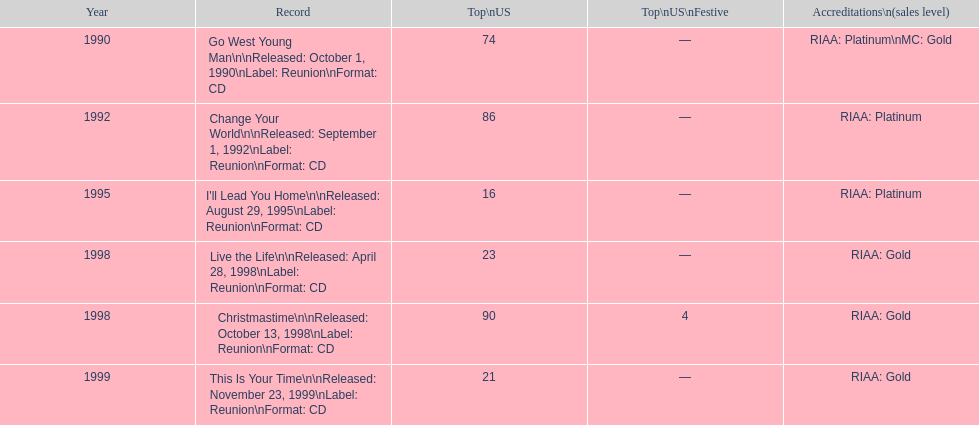Which michael w. smith album achieved the highest position on the us chart? I'll Lead You Home. 